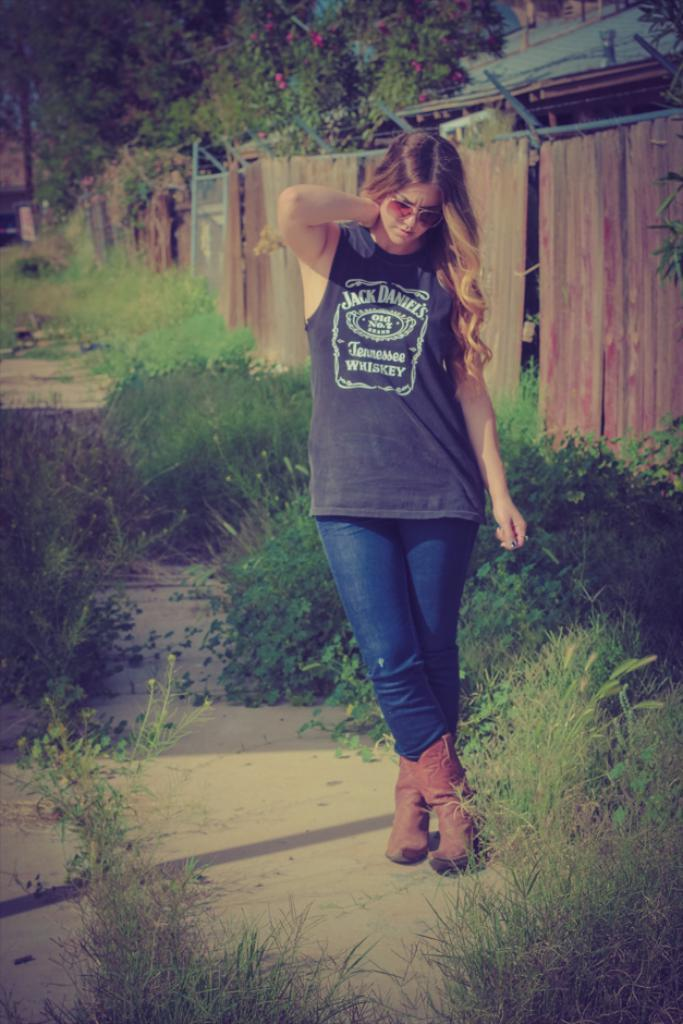Who is the main subject in the image? There is a girl in the image. What is the girl doing in the image? The girl is standing on the ground. What structures can be seen in the image? There is a building and a wooden fence in the image. What type of vegetation is present in the image? Trees are present in the image. How does the girl wound the wren in the image? There is no wren present in the image, and the girl is not wounding any creature. 